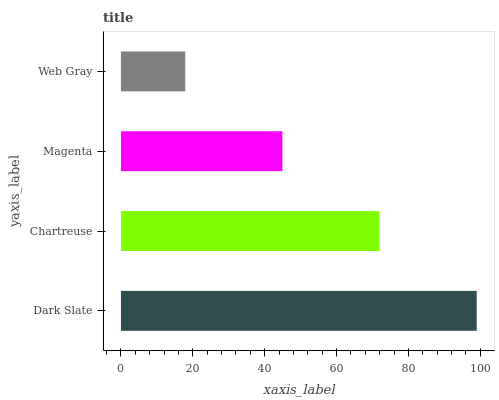Is Web Gray the minimum?
Answer yes or no. Yes. Is Dark Slate the maximum?
Answer yes or no. Yes. Is Chartreuse the minimum?
Answer yes or no. No. Is Chartreuse the maximum?
Answer yes or no. No. Is Dark Slate greater than Chartreuse?
Answer yes or no. Yes. Is Chartreuse less than Dark Slate?
Answer yes or no. Yes. Is Chartreuse greater than Dark Slate?
Answer yes or no. No. Is Dark Slate less than Chartreuse?
Answer yes or no. No. Is Chartreuse the high median?
Answer yes or no. Yes. Is Magenta the low median?
Answer yes or no. Yes. Is Magenta the high median?
Answer yes or no. No. Is Web Gray the low median?
Answer yes or no. No. 